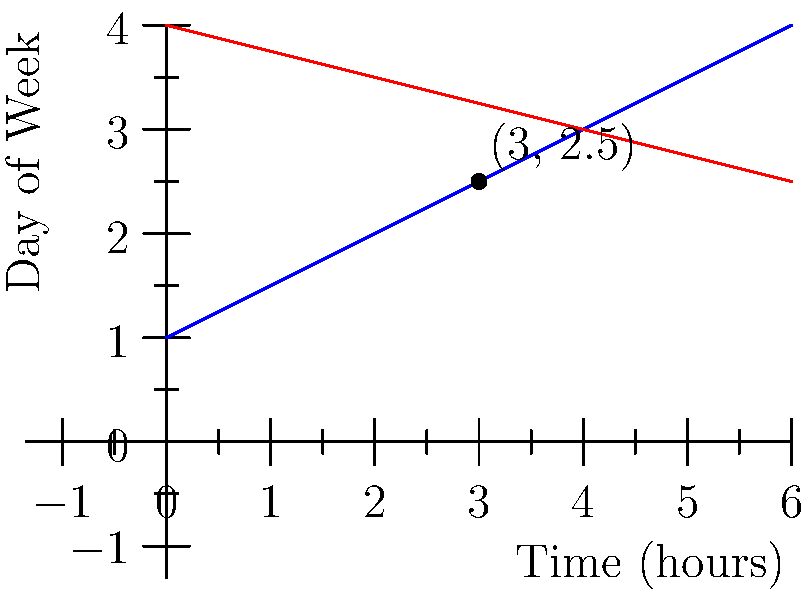As a radio DJ planning your late-night jazz show, you're trying to schedule two guest musicians. Musician A's availability is represented by the equation $y = 0.5x + 1$, while Musician B's availability is represented by $y = -0.25x + 4$, where $x$ is the time in hours after 8 PM, and $y$ is the day of the week (1 = Monday, 7 = Sunday). At what time and day do their schedules intersect, allowing for a potential joint performance? To find the intersection point of the two lines representing the musicians' schedules, we need to solve the system of equations:

1) $y = 0.5x + 1$ (Musician A)
2) $y = -0.25x + 4$ (Musician B)

At the intersection point, both equations are true, so we can set them equal to each other:

3) $0.5x + 1 = -0.25x + 4$

Now, let's solve for $x$:

4) $0.5x + 0.25x = 4 - 1$
5) $0.75x = 3$
6) $x = 3 / 0.75 = 4$

So, the intersection occurs 4 hours after 8 PM, which is midnight (12 AM).

To find the day ($y$-value), we can substitute $x = 4$ into either equation. Let's use Musician A's equation:

7) $y = 0.5(4) + 1 = 2 + 1 = 3$

The $y$-value of 3 corresponds to Wednesday.

Therefore, the schedules intersect at midnight (12 AM) on Wednesday, which is 4 hours after 8 PM on Tuesday.
Answer: Midnight (12 AM) on Wednesday 